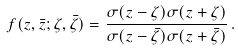<formula> <loc_0><loc_0><loc_500><loc_500>f ( z , \bar { z } ; \zeta , \bar { \zeta } ) = { \frac { \sigma ( { z - \zeta } ) \sigma ( { z + \zeta } ) } { \sigma ( { z - \bar { \zeta } } ) \sigma ( { z + \bar { \zeta } } ) } } \, .</formula> 